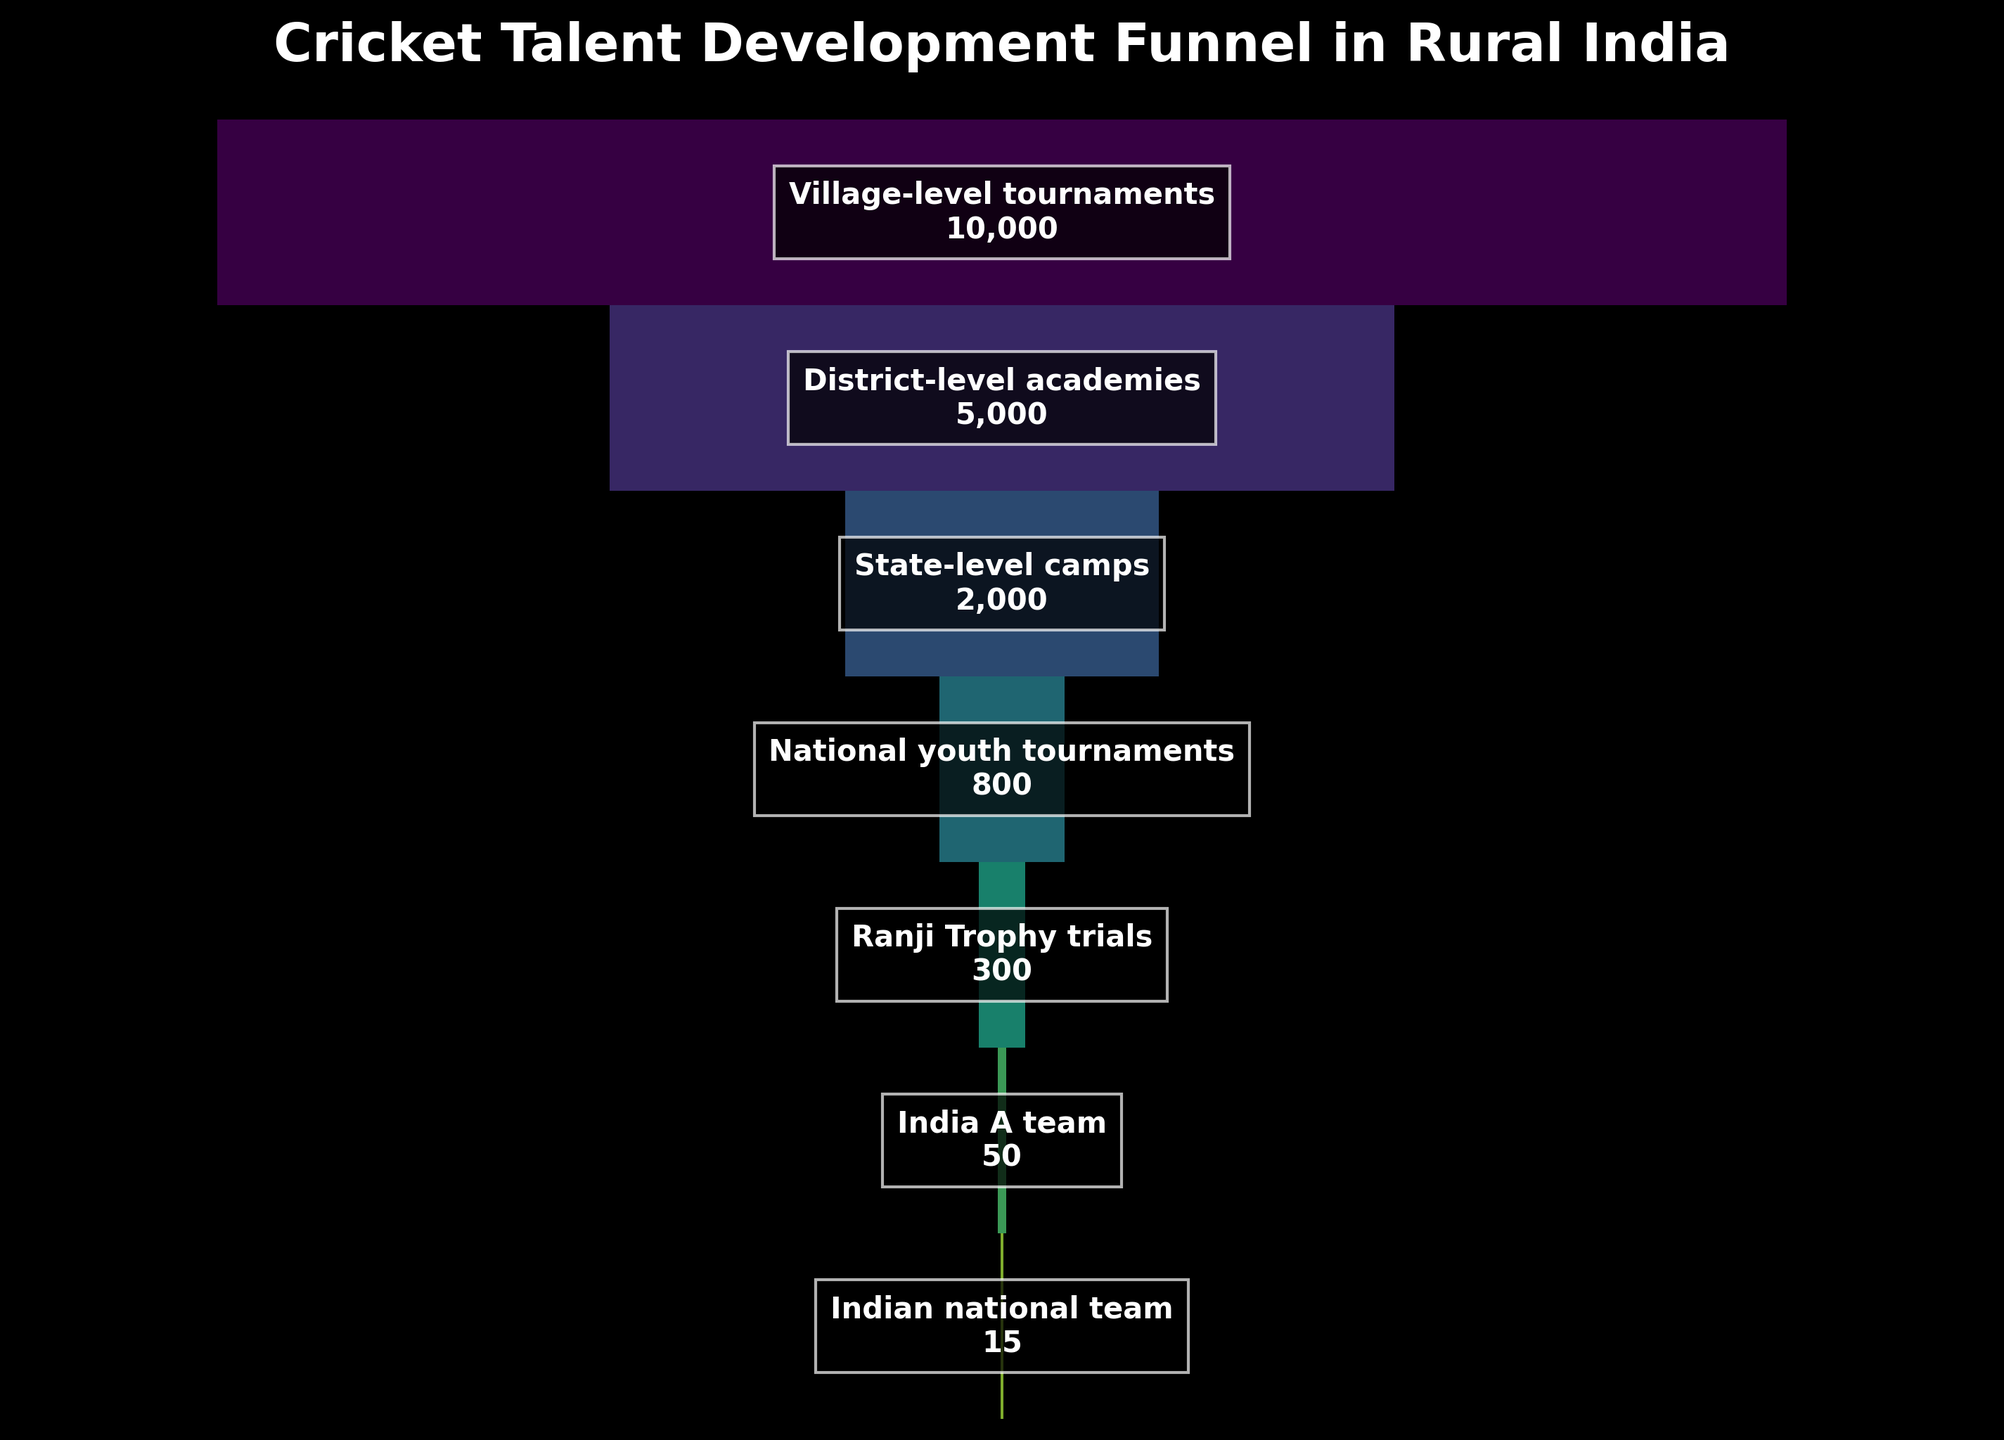What is the title of the plot? The title is usually placed at the top of the figure. In the given plot, it reads, "Cricket Talent Development Funnel in Rural India".
Answer: Cricket Talent Development Funnel in Rural India Which stage has the highest number of players, and how many players does it have? The highest number of players can be found at the widest part of the funnel, which is at the top. The first stage, "Village-level tournaments", has 10,000 players.
Answer: Village-level tournaments, 10,000 How many players participate in state-level camps? The number of players at each stage is labeled within the funnel segments. For the "State-level camps" stage, it shows 2,000 players.
Answer: 2,000 What is the total number of players who make it to the "Ranji Trophy trials"? The number of players at the "Ranji Trophy trials" stage is 300, as labeled within the corresponding funnel segment.
Answer: 300 What is the difference in the number of players between the "District-level academies" and the "India A team"? To find the difference, subtract the number of players in the "India A team" stage from those in the "District-level academies" stage. That is 5,000 - 50 = 4,950.
Answer: 4,950 How many stages are represented in the funnel chart? By counting the different sections of the funnel chart, we can see that there are 7 stages from "Village-level tournaments" to "Indian national team".
Answer: 7 Which stage sees the most significant drop in player numbers compared to the previous stage? By comparing the player count between consecutive stages, the greatest drop is between "State-level camps" (2,000 players) and "National youth tournaments" (800 players). The difference is 2,000 - 800 = 1,200.
Answer: Between State-level camps and National youth tournaments How many players advance from the "National youth tournaments" to the "Ranji Trophy trials"? The number of players advancing from one stage to another is the difference between the two stages. From "National youth tournaments" (800 players) to "Ranji Trophy trials" (300 players), 800 - 300 = 500 players advance.
Answer: 500 What percentage of players from "Village-level tournaments" advance to the "Indian national team"? To find this, divide the number of players who reach the "Indian national team" by the number at the "Village-level tournaments" and multiply by 100. That's (15 / 10,000) * 100 = 0.15%.
Answer: 0.15% 